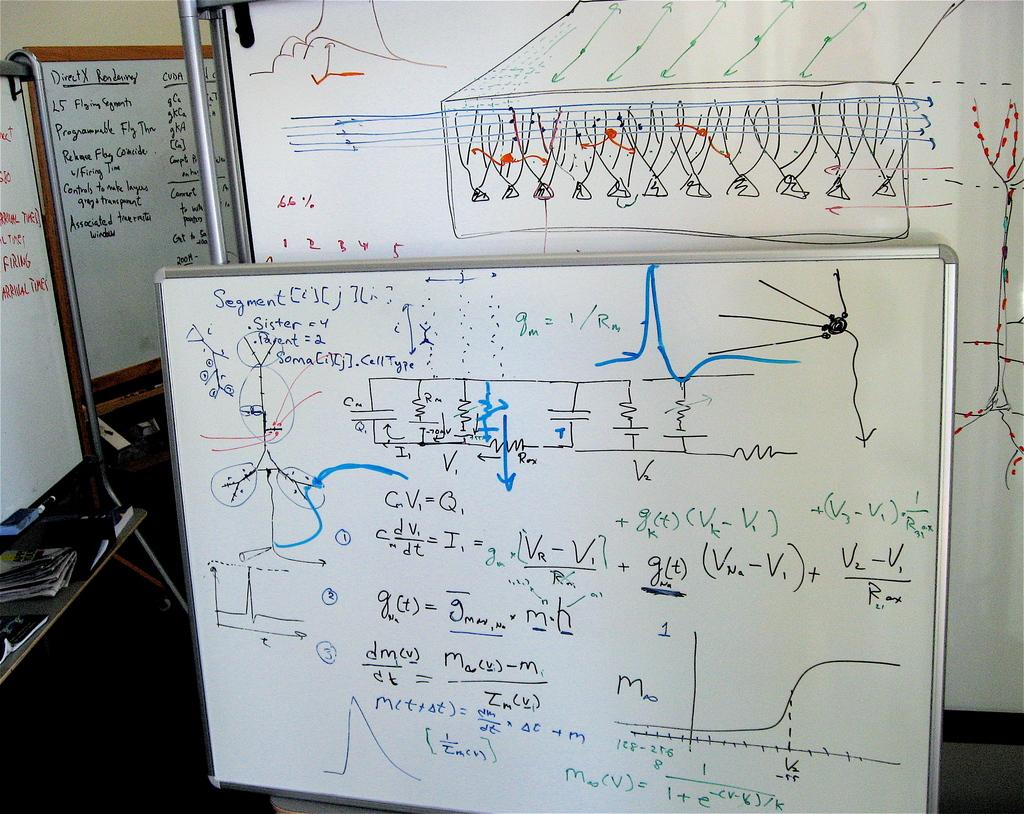Provide a one-sentence caption for the provided image. A white marker board is propped against a wall with trigonometry instructions and problems written in black and blue. 